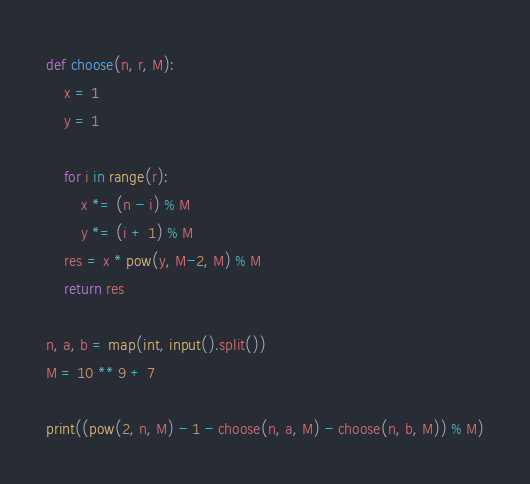<code> <loc_0><loc_0><loc_500><loc_500><_Python_>def choose(n, r, M):
    x = 1
    y = 1

    for i in range(r):
        x *= (n - i) % M
        y *= (i + 1) % M
    res = x * pow(y, M-2, M) % M
    return res

n, a, b = map(int, input().split())
M = 10 ** 9 + 7

print((pow(2, n, M) - 1 - choose(n, a, M) - choose(n, b, M)) % M)</code> 